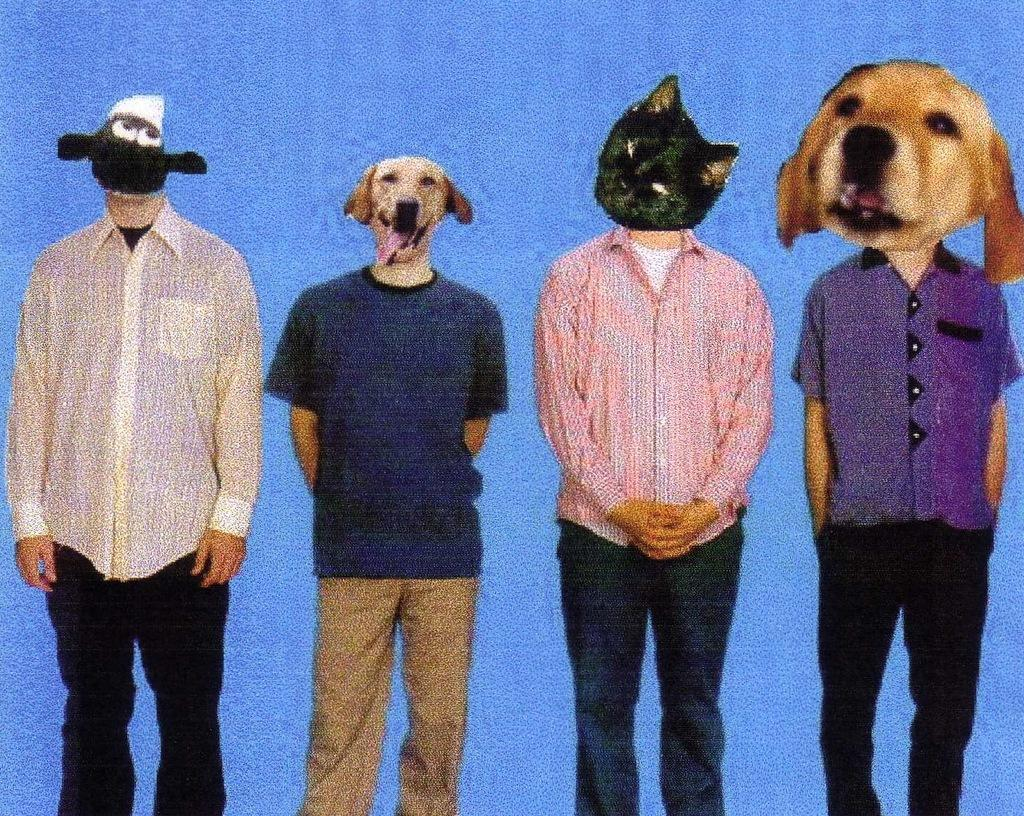How many people are in the image? There are four men standing in the image. What is unique about the appearance of the men's faces? The faces of the men have been edited to resemble cats and dogs. What color is the background of the image? The background of the image is blue in color. What type of paper is being advertised in the image? There is no paper or advertisement present in the image; it features four men with edited faces standing against a blue background. 